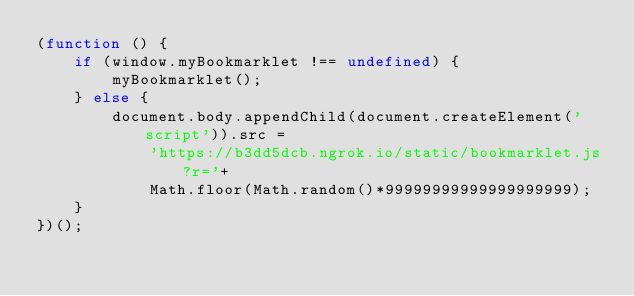<code> <loc_0><loc_0><loc_500><loc_500><_JavaScript_>(function () {
    if (window.myBookmarklet !== undefined) {
        myBookmarklet();
    } else {
        document.body.appendChild(document.createElement('script')).src =
            'https://b3dd5dcb.ngrok.io/static/bookmarklet.js?r='+
            Math.floor(Math.random()*99999999999999999999);
    }
})();</code> 